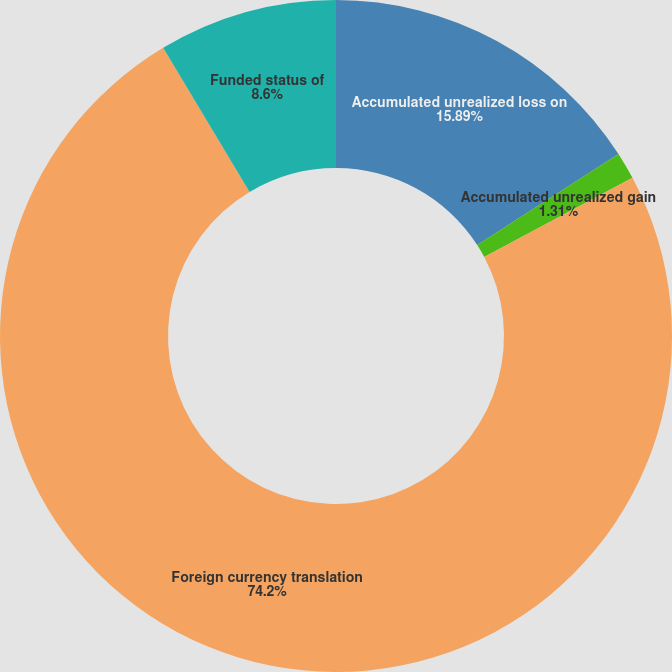Convert chart to OTSL. <chart><loc_0><loc_0><loc_500><loc_500><pie_chart><fcel>Accumulated unrealized loss on<fcel>Accumulated unrealized gain<fcel>Foreign currency translation<fcel>Funded status of<nl><fcel>15.89%<fcel>1.31%<fcel>74.2%<fcel>8.6%<nl></chart> 